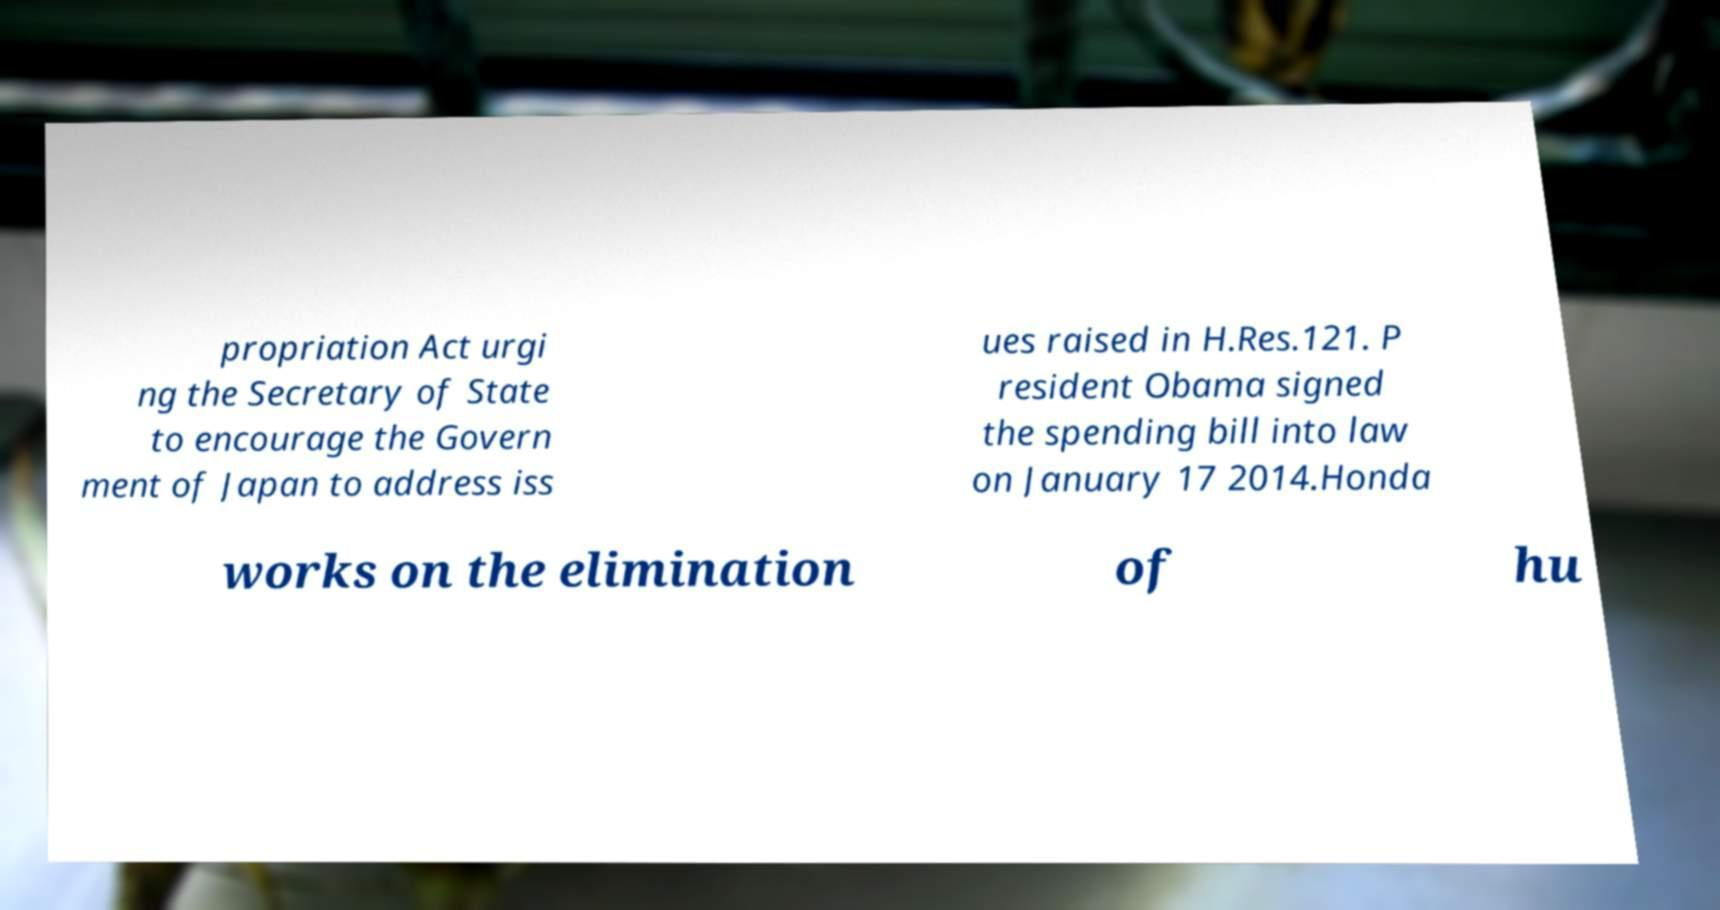Please read and relay the text visible in this image. What does it say? propriation Act urgi ng the Secretary of State to encourage the Govern ment of Japan to address iss ues raised in H.Res.121. P resident Obama signed the spending bill into law on January 17 2014.Honda works on the elimination of hu 